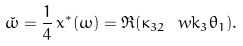<formula> <loc_0><loc_0><loc_500><loc_500>\check { \omega } = \frac { 1 } { 4 } \, x ^ { * } ( \omega ) = \Re ( \kappa _ { 3 2 } \ w k _ { 3 } \theta _ { 1 } ) .</formula> 